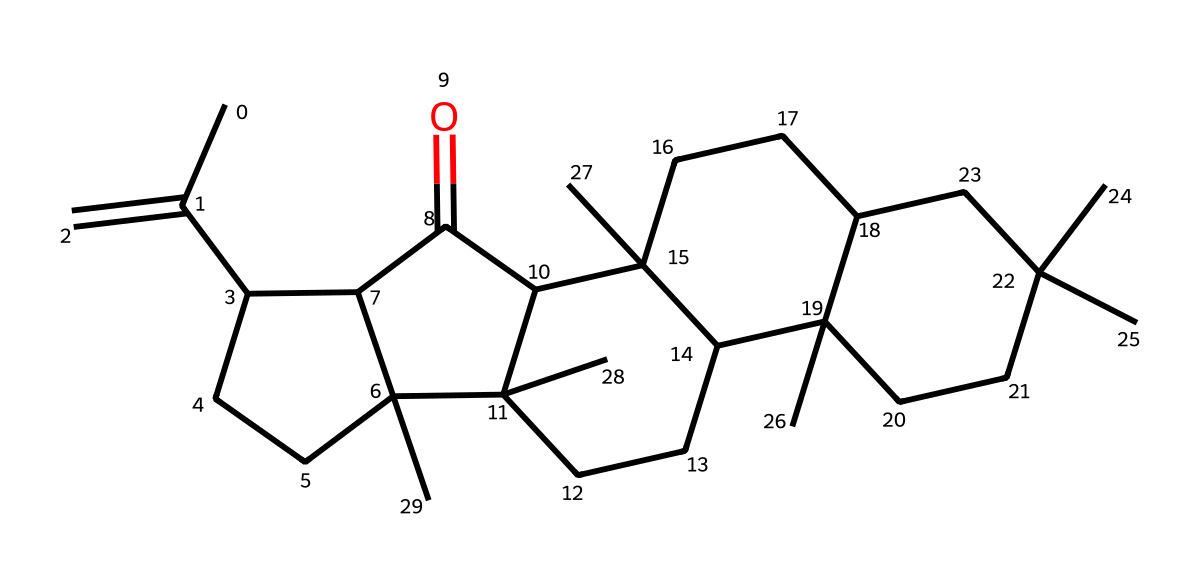What is the total number of carbon atoms in this structure? By examining the SMILES representation, we can count the number of carbon atoms represented by the letter "C". There are 30 carbon atoms indicated in the structure.
Answer: 30 How many rings are present in this chemical structure? Analyzing the SMILES string, we identify numbers that indicate the start and end of rings. There are four distinct numbers (1, 2, 3, and 4) that show that there are four rings present.
Answer: 4 What functional groups can be inferred from the molecular structure? In the provided SMILES, the presence of "C(=O)" indicates a carbonyl group, specifically a ketone function since it's surrounded by carbon atoms.
Answer: ketone What type of chemical is this structure categorized as? Resins used in adhesives and sealants are commonly known to be terpenoids or polyterpenes based on their carbon backbone and cyclic structures, which fits this particular molecular arrangement.
Answer: terpenoid What is the degree of unsaturation in this molecular structure? To determine the degree of unsaturation, we can use the formula (2C + 2 + N - H - X) / 2. Here C = 30, H = 50 (calculated from the structure), giving us (2*30 + 2 - 50) / 2 = 24 / 2 = 12.
Answer: 12 Which part of the chemical structure indicates its adhesive properties? The presence of long carbon chains and cyclic structures in this resin contribute to its adhesive properties due to increased surface area and intermolecular forces.
Answer: long carbon chains 